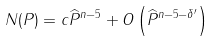Convert formula to latex. <formula><loc_0><loc_0><loc_500><loc_500>N ( P ) = c \widehat { P } ^ { n - 5 } + O \left ( \widehat { P } ^ { n - 5 - \delta ^ { \prime } } \right )</formula> 